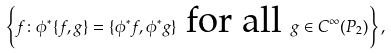Convert formula to latex. <formula><loc_0><loc_0><loc_500><loc_500>\left \{ f \colon \phi ^ { * } \{ f , g \} = \{ \phi ^ { * } f , \phi ^ { * } g \} \text { for all } g \in C ^ { \infty } ( P _ { 2 } ) \right \} ,</formula> 